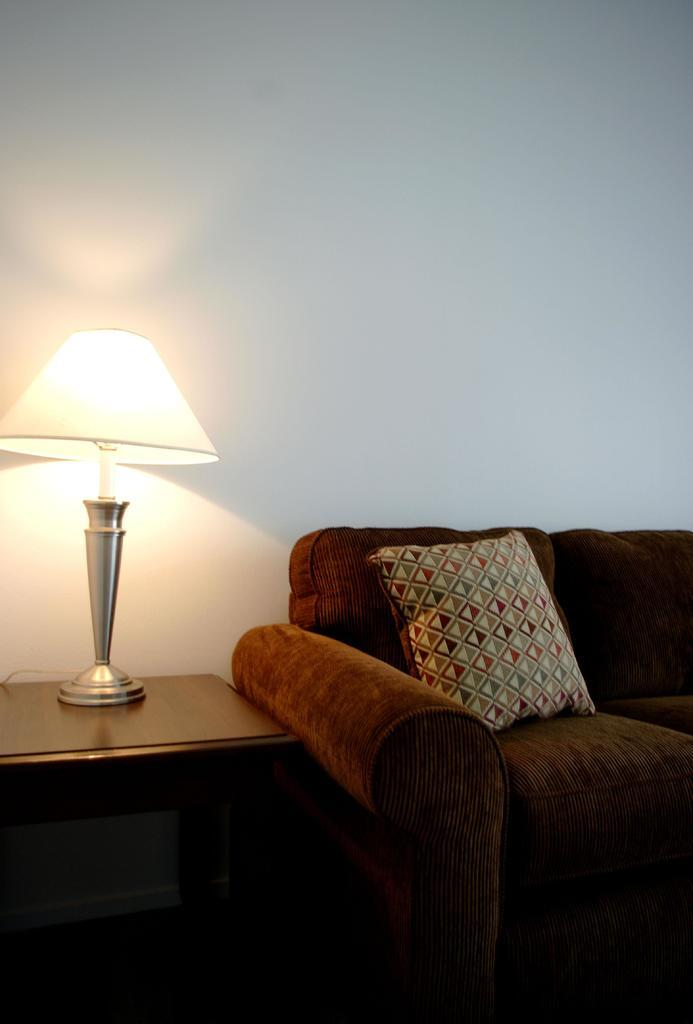What type of furniture is on the ground in the image? There is a sofa set on the ground in the image. What can be seen on the sofa set? There are pillows on the sofa set. What other piece of furniture is present in the image? There is a table in the image. What is placed on the table? There is a lamp on the table. What is visible in the background of the image? There is a wall visible in the image. How many fairies are sitting on the sofa set in the image? There are no fairies present in the image; it features a sofa set with pillows and a table with a lamp. What type of rod is used to control the lamp's brightness in the image? There is no rod visible in the image, and the lamp's brightness cannot be controlled from the image alone. 